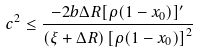<formula> <loc_0><loc_0><loc_500><loc_500>c ^ { 2 } \leq \frac { - 2 b \Delta R [ \rho ( 1 - x _ { 0 } ) ] ^ { \prime } } { ( \xi + \Delta R ) \left [ \rho ( 1 - x _ { 0 } ) \right ] ^ { 2 } }</formula> 